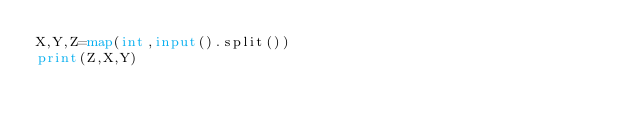<code> <loc_0><loc_0><loc_500><loc_500><_Python_>X,Y,Z=map(int,input().split())
print(Z,X,Y)</code> 